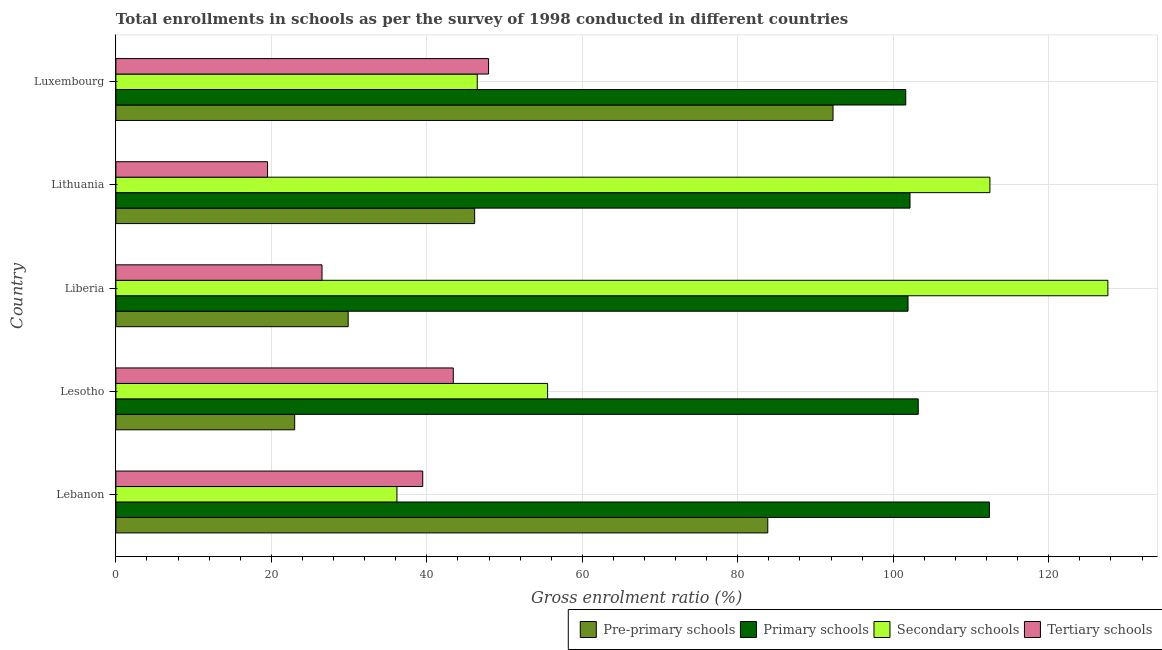How many groups of bars are there?
Make the answer very short. 5. Are the number of bars per tick equal to the number of legend labels?
Keep it short and to the point. Yes. Are the number of bars on each tick of the Y-axis equal?
Your answer should be very brief. Yes. How many bars are there on the 4th tick from the top?
Offer a very short reply. 4. What is the label of the 3rd group of bars from the top?
Your answer should be compact. Liberia. What is the gross enrolment ratio in secondary schools in Liberia?
Offer a terse response. 127.61. Across all countries, what is the maximum gross enrolment ratio in pre-primary schools?
Your answer should be very brief. 92.25. Across all countries, what is the minimum gross enrolment ratio in primary schools?
Keep it short and to the point. 101.6. In which country was the gross enrolment ratio in primary schools maximum?
Give a very brief answer. Lebanon. In which country was the gross enrolment ratio in tertiary schools minimum?
Your answer should be very brief. Lithuania. What is the total gross enrolment ratio in pre-primary schools in the graph?
Your response must be concise. 275.14. What is the difference between the gross enrolment ratio in primary schools in Lesotho and that in Liberia?
Provide a short and direct response. 1.31. What is the difference between the gross enrolment ratio in secondary schools in Lithuania and the gross enrolment ratio in pre-primary schools in Lesotho?
Your response must be concise. 89.43. What is the average gross enrolment ratio in tertiary schools per country?
Provide a succinct answer. 35.37. What is the difference between the gross enrolment ratio in tertiary schools and gross enrolment ratio in pre-primary schools in Lesotho?
Your answer should be compact. 20.4. In how many countries, is the gross enrolment ratio in tertiary schools greater than 100 %?
Provide a short and direct response. 0. What is the ratio of the gross enrolment ratio in primary schools in Lebanon to that in Liberia?
Offer a terse response. 1.1. What is the difference between the highest and the second highest gross enrolment ratio in pre-primary schools?
Your response must be concise. 8.39. What is the difference between the highest and the lowest gross enrolment ratio in pre-primary schools?
Provide a succinct answer. 69.25. Is it the case that in every country, the sum of the gross enrolment ratio in primary schools and gross enrolment ratio in tertiary schools is greater than the sum of gross enrolment ratio in secondary schools and gross enrolment ratio in pre-primary schools?
Offer a terse response. No. What does the 1st bar from the top in Lithuania represents?
Give a very brief answer. Tertiary schools. What does the 2nd bar from the bottom in Luxembourg represents?
Your response must be concise. Primary schools. How many countries are there in the graph?
Offer a terse response. 5. What is the difference between two consecutive major ticks on the X-axis?
Give a very brief answer. 20. Are the values on the major ticks of X-axis written in scientific E-notation?
Your response must be concise. No. Does the graph contain any zero values?
Your answer should be very brief. No. What is the title of the graph?
Offer a very short reply. Total enrollments in schools as per the survey of 1998 conducted in different countries. Does "Social Insurance" appear as one of the legend labels in the graph?
Keep it short and to the point. No. What is the label or title of the X-axis?
Provide a succinct answer. Gross enrolment ratio (%). What is the Gross enrolment ratio (%) in Pre-primary schools in Lebanon?
Make the answer very short. 83.86. What is the Gross enrolment ratio (%) of Primary schools in Lebanon?
Your answer should be very brief. 112.37. What is the Gross enrolment ratio (%) in Secondary schools in Lebanon?
Keep it short and to the point. 36.15. What is the Gross enrolment ratio (%) in Tertiary schools in Lebanon?
Your response must be concise. 39.47. What is the Gross enrolment ratio (%) of Pre-primary schools in Lesotho?
Keep it short and to the point. 23. What is the Gross enrolment ratio (%) of Primary schools in Lesotho?
Ensure brevity in your answer.  103.21. What is the Gross enrolment ratio (%) of Secondary schools in Lesotho?
Provide a succinct answer. 55.54. What is the Gross enrolment ratio (%) of Tertiary schools in Lesotho?
Provide a succinct answer. 43.4. What is the Gross enrolment ratio (%) of Pre-primary schools in Liberia?
Make the answer very short. 29.88. What is the Gross enrolment ratio (%) in Primary schools in Liberia?
Your answer should be compact. 101.9. What is the Gross enrolment ratio (%) of Secondary schools in Liberia?
Keep it short and to the point. 127.61. What is the Gross enrolment ratio (%) in Tertiary schools in Liberia?
Keep it short and to the point. 26.51. What is the Gross enrolment ratio (%) of Pre-primary schools in Lithuania?
Keep it short and to the point. 46.15. What is the Gross enrolment ratio (%) of Primary schools in Lithuania?
Provide a short and direct response. 102.15. What is the Gross enrolment ratio (%) in Secondary schools in Lithuania?
Make the answer very short. 112.43. What is the Gross enrolment ratio (%) in Tertiary schools in Lithuania?
Make the answer very short. 19.51. What is the Gross enrolment ratio (%) of Pre-primary schools in Luxembourg?
Ensure brevity in your answer.  92.25. What is the Gross enrolment ratio (%) of Primary schools in Luxembourg?
Offer a very short reply. 101.6. What is the Gross enrolment ratio (%) in Secondary schools in Luxembourg?
Give a very brief answer. 46.49. What is the Gross enrolment ratio (%) of Tertiary schools in Luxembourg?
Ensure brevity in your answer.  47.94. Across all countries, what is the maximum Gross enrolment ratio (%) of Pre-primary schools?
Your answer should be compact. 92.25. Across all countries, what is the maximum Gross enrolment ratio (%) in Primary schools?
Ensure brevity in your answer.  112.37. Across all countries, what is the maximum Gross enrolment ratio (%) in Secondary schools?
Provide a short and direct response. 127.61. Across all countries, what is the maximum Gross enrolment ratio (%) in Tertiary schools?
Offer a terse response. 47.94. Across all countries, what is the minimum Gross enrolment ratio (%) of Pre-primary schools?
Your response must be concise. 23. Across all countries, what is the minimum Gross enrolment ratio (%) in Primary schools?
Ensure brevity in your answer.  101.6. Across all countries, what is the minimum Gross enrolment ratio (%) in Secondary schools?
Give a very brief answer. 36.15. Across all countries, what is the minimum Gross enrolment ratio (%) of Tertiary schools?
Make the answer very short. 19.51. What is the total Gross enrolment ratio (%) of Pre-primary schools in the graph?
Provide a short and direct response. 275.14. What is the total Gross enrolment ratio (%) in Primary schools in the graph?
Offer a terse response. 521.23. What is the total Gross enrolment ratio (%) in Secondary schools in the graph?
Your answer should be very brief. 378.22. What is the total Gross enrolment ratio (%) in Tertiary schools in the graph?
Provide a succinct answer. 176.84. What is the difference between the Gross enrolment ratio (%) of Pre-primary schools in Lebanon and that in Lesotho?
Your answer should be compact. 60.86. What is the difference between the Gross enrolment ratio (%) in Primary schools in Lebanon and that in Lesotho?
Your response must be concise. 9.16. What is the difference between the Gross enrolment ratio (%) in Secondary schools in Lebanon and that in Lesotho?
Offer a very short reply. -19.38. What is the difference between the Gross enrolment ratio (%) in Tertiary schools in Lebanon and that in Lesotho?
Provide a short and direct response. -3.93. What is the difference between the Gross enrolment ratio (%) in Pre-primary schools in Lebanon and that in Liberia?
Your response must be concise. 53.98. What is the difference between the Gross enrolment ratio (%) in Primary schools in Lebanon and that in Liberia?
Offer a very short reply. 10.47. What is the difference between the Gross enrolment ratio (%) in Secondary schools in Lebanon and that in Liberia?
Offer a very short reply. -91.46. What is the difference between the Gross enrolment ratio (%) of Tertiary schools in Lebanon and that in Liberia?
Provide a succinct answer. 12.96. What is the difference between the Gross enrolment ratio (%) in Pre-primary schools in Lebanon and that in Lithuania?
Provide a short and direct response. 37.71. What is the difference between the Gross enrolment ratio (%) in Primary schools in Lebanon and that in Lithuania?
Your answer should be compact. 10.22. What is the difference between the Gross enrolment ratio (%) of Secondary schools in Lebanon and that in Lithuania?
Provide a short and direct response. -76.28. What is the difference between the Gross enrolment ratio (%) of Tertiary schools in Lebanon and that in Lithuania?
Give a very brief answer. 19.96. What is the difference between the Gross enrolment ratio (%) of Pre-primary schools in Lebanon and that in Luxembourg?
Make the answer very short. -8.39. What is the difference between the Gross enrolment ratio (%) of Primary schools in Lebanon and that in Luxembourg?
Make the answer very short. 10.76. What is the difference between the Gross enrolment ratio (%) in Secondary schools in Lebanon and that in Luxembourg?
Make the answer very short. -10.33. What is the difference between the Gross enrolment ratio (%) in Tertiary schools in Lebanon and that in Luxembourg?
Ensure brevity in your answer.  -8.47. What is the difference between the Gross enrolment ratio (%) in Pre-primary schools in Lesotho and that in Liberia?
Keep it short and to the point. -6.88. What is the difference between the Gross enrolment ratio (%) in Primary schools in Lesotho and that in Liberia?
Your answer should be compact. 1.31. What is the difference between the Gross enrolment ratio (%) in Secondary schools in Lesotho and that in Liberia?
Provide a succinct answer. -72.07. What is the difference between the Gross enrolment ratio (%) of Tertiary schools in Lesotho and that in Liberia?
Your answer should be compact. 16.89. What is the difference between the Gross enrolment ratio (%) of Pre-primary schools in Lesotho and that in Lithuania?
Give a very brief answer. -23.15. What is the difference between the Gross enrolment ratio (%) in Primary schools in Lesotho and that in Lithuania?
Ensure brevity in your answer.  1.06. What is the difference between the Gross enrolment ratio (%) in Secondary schools in Lesotho and that in Lithuania?
Keep it short and to the point. -56.89. What is the difference between the Gross enrolment ratio (%) of Tertiary schools in Lesotho and that in Lithuania?
Offer a terse response. 23.89. What is the difference between the Gross enrolment ratio (%) in Pre-primary schools in Lesotho and that in Luxembourg?
Your answer should be very brief. -69.25. What is the difference between the Gross enrolment ratio (%) of Primary schools in Lesotho and that in Luxembourg?
Your answer should be compact. 1.61. What is the difference between the Gross enrolment ratio (%) of Secondary schools in Lesotho and that in Luxembourg?
Provide a short and direct response. 9.05. What is the difference between the Gross enrolment ratio (%) of Tertiary schools in Lesotho and that in Luxembourg?
Give a very brief answer. -4.54. What is the difference between the Gross enrolment ratio (%) of Pre-primary schools in Liberia and that in Lithuania?
Your answer should be compact. -16.27. What is the difference between the Gross enrolment ratio (%) of Primary schools in Liberia and that in Lithuania?
Your response must be concise. -0.25. What is the difference between the Gross enrolment ratio (%) in Secondary schools in Liberia and that in Lithuania?
Offer a very short reply. 15.18. What is the difference between the Gross enrolment ratio (%) of Tertiary schools in Liberia and that in Lithuania?
Your answer should be compact. 7.01. What is the difference between the Gross enrolment ratio (%) of Pre-primary schools in Liberia and that in Luxembourg?
Your answer should be compact. -62.37. What is the difference between the Gross enrolment ratio (%) in Primary schools in Liberia and that in Luxembourg?
Your response must be concise. 0.29. What is the difference between the Gross enrolment ratio (%) in Secondary schools in Liberia and that in Luxembourg?
Offer a terse response. 81.12. What is the difference between the Gross enrolment ratio (%) of Tertiary schools in Liberia and that in Luxembourg?
Make the answer very short. -21.43. What is the difference between the Gross enrolment ratio (%) of Pre-primary schools in Lithuania and that in Luxembourg?
Your answer should be very brief. -46.1. What is the difference between the Gross enrolment ratio (%) of Primary schools in Lithuania and that in Luxembourg?
Your response must be concise. 0.55. What is the difference between the Gross enrolment ratio (%) in Secondary schools in Lithuania and that in Luxembourg?
Offer a terse response. 65.95. What is the difference between the Gross enrolment ratio (%) in Tertiary schools in Lithuania and that in Luxembourg?
Offer a terse response. -28.43. What is the difference between the Gross enrolment ratio (%) in Pre-primary schools in Lebanon and the Gross enrolment ratio (%) in Primary schools in Lesotho?
Give a very brief answer. -19.35. What is the difference between the Gross enrolment ratio (%) of Pre-primary schools in Lebanon and the Gross enrolment ratio (%) of Secondary schools in Lesotho?
Make the answer very short. 28.32. What is the difference between the Gross enrolment ratio (%) in Pre-primary schools in Lebanon and the Gross enrolment ratio (%) in Tertiary schools in Lesotho?
Provide a short and direct response. 40.45. What is the difference between the Gross enrolment ratio (%) of Primary schools in Lebanon and the Gross enrolment ratio (%) of Secondary schools in Lesotho?
Your response must be concise. 56.83. What is the difference between the Gross enrolment ratio (%) in Primary schools in Lebanon and the Gross enrolment ratio (%) in Tertiary schools in Lesotho?
Offer a terse response. 68.96. What is the difference between the Gross enrolment ratio (%) in Secondary schools in Lebanon and the Gross enrolment ratio (%) in Tertiary schools in Lesotho?
Ensure brevity in your answer.  -7.25. What is the difference between the Gross enrolment ratio (%) of Pre-primary schools in Lebanon and the Gross enrolment ratio (%) of Primary schools in Liberia?
Your answer should be very brief. -18.04. What is the difference between the Gross enrolment ratio (%) in Pre-primary schools in Lebanon and the Gross enrolment ratio (%) in Secondary schools in Liberia?
Provide a succinct answer. -43.75. What is the difference between the Gross enrolment ratio (%) in Pre-primary schools in Lebanon and the Gross enrolment ratio (%) in Tertiary schools in Liberia?
Your answer should be compact. 57.34. What is the difference between the Gross enrolment ratio (%) in Primary schools in Lebanon and the Gross enrolment ratio (%) in Secondary schools in Liberia?
Offer a terse response. -15.24. What is the difference between the Gross enrolment ratio (%) in Primary schools in Lebanon and the Gross enrolment ratio (%) in Tertiary schools in Liberia?
Offer a terse response. 85.85. What is the difference between the Gross enrolment ratio (%) of Secondary schools in Lebanon and the Gross enrolment ratio (%) of Tertiary schools in Liberia?
Offer a terse response. 9.64. What is the difference between the Gross enrolment ratio (%) of Pre-primary schools in Lebanon and the Gross enrolment ratio (%) of Primary schools in Lithuania?
Keep it short and to the point. -18.29. What is the difference between the Gross enrolment ratio (%) of Pre-primary schools in Lebanon and the Gross enrolment ratio (%) of Secondary schools in Lithuania?
Your response must be concise. -28.57. What is the difference between the Gross enrolment ratio (%) of Pre-primary schools in Lebanon and the Gross enrolment ratio (%) of Tertiary schools in Lithuania?
Offer a very short reply. 64.35. What is the difference between the Gross enrolment ratio (%) of Primary schools in Lebanon and the Gross enrolment ratio (%) of Secondary schools in Lithuania?
Provide a succinct answer. -0.06. What is the difference between the Gross enrolment ratio (%) in Primary schools in Lebanon and the Gross enrolment ratio (%) in Tertiary schools in Lithuania?
Offer a terse response. 92.86. What is the difference between the Gross enrolment ratio (%) in Secondary schools in Lebanon and the Gross enrolment ratio (%) in Tertiary schools in Lithuania?
Offer a terse response. 16.64. What is the difference between the Gross enrolment ratio (%) of Pre-primary schools in Lebanon and the Gross enrolment ratio (%) of Primary schools in Luxembourg?
Ensure brevity in your answer.  -17.75. What is the difference between the Gross enrolment ratio (%) in Pre-primary schools in Lebanon and the Gross enrolment ratio (%) in Secondary schools in Luxembourg?
Offer a terse response. 37.37. What is the difference between the Gross enrolment ratio (%) in Pre-primary schools in Lebanon and the Gross enrolment ratio (%) in Tertiary schools in Luxembourg?
Provide a short and direct response. 35.92. What is the difference between the Gross enrolment ratio (%) in Primary schools in Lebanon and the Gross enrolment ratio (%) in Secondary schools in Luxembourg?
Make the answer very short. 65.88. What is the difference between the Gross enrolment ratio (%) of Primary schools in Lebanon and the Gross enrolment ratio (%) of Tertiary schools in Luxembourg?
Provide a succinct answer. 64.43. What is the difference between the Gross enrolment ratio (%) in Secondary schools in Lebanon and the Gross enrolment ratio (%) in Tertiary schools in Luxembourg?
Make the answer very short. -11.79. What is the difference between the Gross enrolment ratio (%) in Pre-primary schools in Lesotho and the Gross enrolment ratio (%) in Primary schools in Liberia?
Offer a terse response. -78.9. What is the difference between the Gross enrolment ratio (%) of Pre-primary schools in Lesotho and the Gross enrolment ratio (%) of Secondary schools in Liberia?
Offer a very short reply. -104.61. What is the difference between the Gross enrolment ratio (%) of Pre-primary schools in Lesotho and the Gross enrolment ratio (%) of Tertiary schools in Liberia?
Your response must be concise. -3.51. What is the difference between the Gross enrolment ratio (%) of Primary schools in Lesotho and the Gross enrolment ratio (%) of Secondary schools in Liberia?
Offer a very short reply. -24.4. What is the difference between the Gross enrolment ratio (%) of Primary schools in Lesotho and the Gross enrolment ratio (%) of Tertiary schools in Liberia?
Ensure brevity in your answer.  76.7. What is the difference between the Gross enrolment ratio (%) in Secondary schools in Lesotho and the Gross enrolment ratio (%) in Tertiary schools in Liberia?
Provide a short and direct response. 29.02. What is the difference between the Gross enrolment ratio (%) of Pre-primary schools in Lesotho and the Gross enrolment ratio (%) of Primary schools in Lithuania?
Ensure brevity in your answer.  -79.15. What is the difference between the Gross enrolment ratio (%) in Pre-primary schools in Lesotho and the Gross enrolment ratio (%) in Secondary schools in Lithuania?
Keep it short and to the point. -89.43. What is the difference between the Gross enrolment ratio (%) of Pre-primary schools in Lesotho and the Gross enrolment ratio (%) of Tertiary schools in Lithuania?
Ensure brevity in your answer.  3.49. What is the difference between the Gross enrolment ratio (%) of Primary schools in Lesotho and the Gross enrolment ratio (%) of Secondary schools in Lithuania?
Your answer should be compact. -9.22. What is the difference between the Gross enrolment ratio (%) in Primary schools in Lesotho and the Gross enrolment ratio (%) in Tertiary schools in Lithuania?
Keep it short and to the point. 83.7. What is the difference between the Gross enrolment ratio (%) of Secondary schools in Lesotho and the Gross enrolment ratio (%) of Tertiary schools in Lithuania?
Offer a very short reply. 36.03. What is the difference between the Gross enrolment ratio (%) in Pre-primary schools in Lesotho and the Gross enrolment ratio (%) in Primary schools in Luxembourg?
Provide a short and direct response. -78.6. What is the difference between the Gross enrolment ratio (%) of Pre-primary schools in Lesotho and the Gross enrolment ratio (%) of Secondary schools in Luxembourg?
Ensure brevity in your answer.  -23.49. What is the difference between the Gross enrolment ratio (%) of Pre-primary schools in Lesotho and the Gross enrolment ratio (%) of Tertiary schools in Luxembourg?
Your answer should be very brief. -24.94. What is the difference between the Gross enrolment ratio (%) of Primary schools in Lesotho and the Gross enrolment ratio (%) of Secondary schools in Luxembourg?
Your answer should be very brief. 56.72. What is the difference between the Gross enrolment ratio (%) in Primary schools in Lesotho and the Gross enrolment ratio (%) in Tertiary schools in Luxembourg?
Make the answer very short. 55.27. What is the difference between the Gross enrolment ratio (%) in Secondary schools in Lesotho and the Gross enrolment ratio (%) in Tertiary schools in Luxembourg?
Your answer should be compact. 7.6. What is the difference between the Gross enrolment ratio (%) of Pre-primary schools in Liberia and the Gross enrolment ratio (%) of Primary schools in Lithuania?
Your answer should be compact. -72.27. What is the difference between the Gross enrolment ratio (%) in Pre-primary schools in Liberia and the Gross enrolment ratio (%) in Secondary schools in Lithuania?
Offer a very short reply. -82.55. What is the difference between the Gross enrolment ratio (%) in Pre-primary schools in Liberia and the Gross enrolment ratio (%) in Tertiary schools in Lithuania?
Ensure brevity in your answer.  10.37. What is the difference between the Gross enrolment ratio (%) of Primary schools in Liberia and the Gross enrolment ratio (%) of Secondary schools in Lithuania?
Make the answer very short. -10.53. What is the difference between the Gross enrolment ratio (%) of Primary schools in Liberia and the Gross enrolment ratio (%) of Tertiary schools in Lithuania?
Make the answer very short. 82.39. What is the difference between the Gross enrolment ratio (%) of Secondary schools in Liberia and the Gross enrolment ratio (%) of Tertiary schools in Lithuania?
Your answer should be compact. 108.1. What is the difference between the Gross enrolment ratio (%) in Pre-primary schools in Liberia and the Gross enrolment ratio (%) in Primary schools in Luxembourg?
Provide a succinct answer. -71.72. What is the difference between the Gross enrolment ratio (%) in Pre-primary schools in Liberia and the Gross enrolment ratio (%) in Secondary schools in Luxembourg?
Provide a short and direct response. -16.6. What is the difference between the Gross enrolment ratio (%) of Pre-primary schools in Liberia and the Gross enrolment ratio (%) of Tertiary schools in Luxembourg?
Your answer should be compact. -18.06. What is the difference between the Gross enrolment ratio (%) in Primary schools in Liberia and the Gross enrolment ratio (%) in Secondary schools in Luxembourg?
Provide a succinct answer. 55.41. What is the difference between the Gross enrolment ratio (%) in Primary schools in Liberia and the Gross enrolment ratio (%) in Tertiary schools in Luxembourg?
Provide a short and direct response. 53.96. What is the difference between the Gross enrolment ratio (%) in Secondary schools in Liberia and the Gross enrolment ratio (%) in Tertiary schools in Luxembourg?
Provide a succinct answer. 79.67. What is the difference between the Gross enrolment ratio (%) of Pre-primary schools in Lithuania and the Gross enrolment ratio (%) of Primary schools in Luxembourg?
Your answer should be compact. -55.45. What is the difference between the Gross enrolment ratio (%) of Pre-primary schools in Lithuania and the Gross enrolment ratio (%) of Secondary schools in Luxembourg?
Your response must be concise. -0.34. What is the difference between the Gross enrolment ratio (%) of Pre-primary schools in Lithuania and the Gross enrolment ratio (%) of Tertiary schools in Luxembourg?
Give a very brief answer. -1.79. What is the difference between the Gross enrolment ratio (%) of Primary schools in Lithuania and the Gross enrolment ratio (%) of Secondary schools in Luxembourg?
Provide a succinct answer. 55.66. What is the difference between the Gross enrolment ratio (%) in Primary schools in Lithuania and the Gross enrolment ratio (%) in Tertiary schools in Luxembourg?
Give a very brief answer. 54.21. What is the difference between the Gross enrolment ratio (%) of Secondary schools in Lithuania and the Gross enrolment ratio (%) of Tertiary schools in Luxembourg?
Provide a short and direct response. 64.49. What is the average Gross enrolment ratio (%) of Pre-primary schools per country?
Ensure brevity in your answer.  55.03. What is the average Gross enrolment ratio (%) of Primary schools per country?
Your answer should be very brief. 104.25. What is the average Gross enrolment ratio (%) of Secondary schools per country?
Your answer should be compact. 75.64. What is the average Gross enrolment ratio (%) in Tertiary schools per country?
Your answer should be compact. 35.37. What is the difference between the Gross enrolment ratio (%) in Pre-primary schools and Gross enrolment ratio (%) in Primary schools in Lebanon?
Your response must be concise. -28.51. What is the difference between the Gross enrolment ratio (%) in Pre-primary schools and Gross enrolment ratio (%) in Secondary schools in Lebanon?
Give a very brief answer. 47.7. What is the difference between the Gross enrolment ratio (%) in Pre-primary schools and Gross enrolment ratio (%) in Tertiary schools in Lebanon?
Your answer should be compact. 44.39. What is the difference between the Gross enrolment ratio (%) of Primary schools and Gross enrolment ratio (%) of Secondary schools in Lebanon?
Offer a very short reply. 76.22. What is the difference between the Gross enrolment ratio (%) of Primary schools and Gross enrolment ratio (%) of Tertiary schools in Lebanon?
Ensure brevity in your answer.  72.9. What is the difference between the Gross enrolment ratio (%) of Secondary schools and Gross enrolment ratio (%) of Tertiary schools in Lebanon?
Offer a terse response. -3.32. What is the difference between the Gross enrolment ratio (%) of Pre-primary schools and Gross enrolment ratio (%) of Primary schools in Lesotho?
Provide a short and direct response. -80.21. What is the difference between the Gross enrolment ratio (%) of Pre-primary schools and Gross enrolment ratio (%) of Secondary schools in Lesotho?
Ensure brevity in your answer.  -32.54. What is the difference between the Gross enrolment ratio (%) in Pre-primary schools and Gross enrolment ratio (%) in Tertiary schools in Lesotho?
Your answer should be very brief. -20.4. What is the difference between the Gross enrolment ratio (%) in Primary schools and Gross enrolment ratio (%) in Secondary schools in Lesotho?
Your answer should be compact. 47.67. What is the difference between the Gross enrolment ratio (%) of Primary schools and Gross enrolment ratio (%) of Tertiary schools in Lesotho?
Ensure brevity in your answer.  59.81. What is the difference between the Gross enrolment ratio (%) in Secondary schools and Gross enrolment ratio (%) in Tertiary schools in Lesotho?
Your answer should be very brief. 12.13. What is the difference between the Gross enrolment ratio (%) in Pre-primary schools and Gross enrolment ratio (%) in Primary schools in Liberia?
Make the answer very short. -72.02. What is the difference between the Gross enrolment ratio (%) in Pre-primary schools and Gross enrolment ratio (%) in Secondary schools in Liberia?
Your answer should be very brief. -97.73. What is the difference between the Gross enrolment ratio (%) in Pre-primary schools and Gross enrolment ratio (%) in Tertiary schools in Liberia?
Ensure brevity in your answer.  3.37. What is the difference between the Gross enrolment ratio (%) of Primary schools and Gross enrolment ratio (%) of Secondary schools in Liberia?
Give a very brief answer. -25.71. What is the difference between the Gross enrolment ratio (%) of Primary schools and Gross enrolment ratio (%) of Tertiary schools in Liberia?
Your answer should be compact. 75.38. What is the difference between the Gross enrolment ratio (%) of Secondary schools and Gross enrolment ratio (%) of Tertiary schools in Liberia?
Ensure brevity in your answer.  101.09. What is the difference between the Gross enrolment ratio (%) in Pre-primary schools and Gross enrolment ratio (%) in Primary schools in Lithuania?
Ensure brevity in your answer.  -56. What is the difference between the Gross enrolment ratio (%) in Pre-primary schools and Gross enrolment ratio (%) in Secondary schools in Lithuania?
Provide a succinct answer. -66.28. What is the difference between the Gross enrolment ratio (%) of Pre-primary schools and Gross enrolment ratio (%) of Tertiary schools in Lithuania?
Make the answer very short. 26.64. What is the difference between the Gross enrolment ratio (%) of Primary schools and Gross enrolment ratio (%) of Secondary schools in Lithuania?
Your answer should be very brief. -10.28. What is the difference between the Gross enrolment ratio (%) of Primary schools and Gross enrolment ratio (%) of Tertiary schools in Lithuania?
Give a very brief answer. 82.64. What is the difference between the Gross enrolment ratio (%) of Secondary schools and Gross enrolment ratio (%) of Tertiary schools in Lithuania?
Provide a succinct answer. 92.92. What is the difference between the Gross enrolment ratio (%) of Pre-primary schools and Gross enrolment ratio (%) of Primary schools in Luxembourg?
Keep it short and to the point. -9.35. What is the difference between the Gross enrolment ratio (%) of Pre-primary schools and Gross enrolment ratio (%) of Secondary schools in Luxembourg?
Give a very brief answer. 45.76. What is the difference between the Gross enrolment ratio (%) in Pre-primary schools and Gross enrolment ratio (%) in Tertiary schools in Luxembourg?
Make the answer very short. 44.31. What is the difference between the Gross enrolment ratio (%) of Primary schools and Gross enrolment ratio (%) of Secondary schools in Luxembourg?
Make the answer very short. 55.12. What is the difference between the Gross enrolment ratio (%) of Primary schools and Gross enrolment ratio (%) of Tertiary schools in Luxembourg?
Your answer should be very brief. 53.66. What is the difference between the Gross enrolment ratio (%) in Secondary schools and Gross enrolment ratio (%) in Tertiary schools in Luxembourg?
Provide a short and direct response. -1.45. What is the ratio of the Gross enrolment ratio (%) in Pre-primary schools in Lebanon to that in Lesotho?
Offer a terse response. 3.65. What is the ratio of the Gross enrolment ratio (%) of Primary schools in Lebanon to that in Lesotho?
Give a very brief answer. 1.09. What is the ratio of the Gross enrolment ratio (%) of Secondary schools in Lebanon to that in Lesotho?
Make the answer very short. 0.65. What is the ratio of the Gross enrolment ratio (%) in Tertiary schools in Lebanon to that in Lesotho?
Your response must be concise. 0.91. What is the ratio of the Gross enrolment ratio (%) in Pre-primary schools in Lebanon to that in Liberia?
Offer a very short reply. 2.81. What is the ratio of the Gross enrolment ratio (%) of Primary schools in Lebanon to that in Liberia?
Make the answer very short. 1.1. What is the ratio of the Gross enrolment ratio (%) of Secondary schools in Lebanon to that in Liberia?
Make the answer very short. 0.28. What is the ratio of the Gross enrolment ratio (%) of Tertiary schools in Lebanon to that in Liberia?
Offer a terse response. 1.49. What is the ratio of the Gross enrolment ratio (%) in Pre-primary schools in Lebanon to that in Lithuania?
Make the answer very short. 1.82. What is the ratio of the Gross enrolment ratio (%) in Primary schools in Lebanon to that in Lithuania?
Keep it short and to the point. 1.1. What is the ratio of the Gross enrolment ratio (%) of Secondary schools in Lebanon to that in Lithuania?
Give a very brief answer. 0.32. What is the ratio of the Gross enrolment ratio (%) in Tertiary schools in Lebanon to that in Lithuania?
Keep it short and to the point. 2.02. What is the ratio of the Gross enrolment ratio (%) of Pre-primary schools in Lebanon to that in Luxembourg?
Make the answer very short. 0.91. What is the ratio of the Gross enrolment ratio (%) in Primary schools in Lebanon to that in Luxembourg?
Offer a very short reply. 1.11. What is the ratio of the Gross enrolment ratio (%) in Secondary schools in Lebanon to that in Luxembourg?
Keep it short and to the point. 0.78. What is the ratio of the Gross enrolment ratio (%) in Tertiary schools in Lebanon to that in Luxembourg?
Ensure brevity in your answer.  0.82. What is the ratio of the Gross enrolment ratio (%) in Pre-primary schools in Lesotho to that in Liberia?
Ensure brevity in your answer.  0.77. What is the ratio of the Gross enrolment ratio (%) of Primary schools in Lesotho to that in Liberia?
Make the answer very short. 1.01. What is the ratio of the Gross enrolment ratio (%) of Secondary schools in Lesotho to that in Liberia?
Offer a very short reply. 0.44. What is the ratio of the Gross enrolment ratio (%) in Tertiary schools in Lesotho to that in Liberia?
Provide a short and direct response. 1.64. What is the ratio of the Gross enrolment ratio (%) of Pre-primary schools in Lesotho to that in Lithuania?
Provide a short and direct response. 0.5. What is the ratio of the Gross enrolment ratio (%) of Primary schools in Lesotho to that in Lithuania?
Your answer should be compact. 1.01. What is the ratio of the Gross enrolment ratio (%) in Secondary schools in Lesotho to that in Lithuania?
Ensure brevity in your answer.  0.49. What is the ratio of the Gross enrolment ratio (%) of Tertiary schools in Lesotho to that in Lithuania?
Your answer should be very brief. 2.22. What is the ratio of the Gross enrolment ratio (%) of Pre-primary schools in Lesotho to that in Luxembourg?
Provide a short and direct response. 0.25. What is the ratio of the Gross enrolment ratio (%) of Primary schools in Lesotho to that in Luxembourg?
Provide a succinct answer. 1.02. What is the ratio of the Gross enrolment ratio (%) in Secondary schools in Lesotho to that in Luxembourg?
Provide a short and direct response. 1.19. What is the ratio of the Gross enrolment ratio (%) of Tertiary schools in Lesotho to that in Luxembourg?
Your response must be concise. 0.91. What is the ratio of the Gross enrolment ratio (%) of Pre-primary schools in Liberia to that in Lithuania?
Your response must be concise. 0.65. What is the ratio of the Gross enrolment ratio (%) in Secondary schools in Liberia to that in Lithuania?
Ensure brevity in your answer.  1.14. What is the ratio of the Gross enrolment ratio (%) in Tertiary schools in Liberia to that in Lithuania?
Your response must be concise. 1.36. What is the ratio of the Gross enrolment ratio (%) of Pre-primary schools in Liberia to that in Luxembourg?
Provide a short and direct response. 0.32. What is the ratio of the Gross enrolment ratio (%) of Secondary schools in Liberia to that in Luxembourg?
Give a very brief answer. 2.75. What is the ratio of the Gross enrolment ratio (%) in Tertiary schools in Liberia to that in Luxembourg?
Your answer should be compact. 0.55. What is the ratio of the Gross enrolment ratio (%) in Pre-primary schools in Lithuania to that in Luxembourg?
Offer a terse response. 0.5. What is the ratio of the Gross enrolment ratio (%) in Primary schools in Lithuania to that in Luxembourg?
Give a very brief answer. 1.01. What is the ratio of the Gross enrolment ratio (%) in Secondary schools in Lithuania to that in Luxembourg?
Give a very brief answer. 2.42. What is the ratio of the Gross enrolment ratio (%) of Tertiary schools in Lithuania to that in Luxembourg?
Offer a terse response. 0.41. What is the difference between the highest and the second highest Gross enrolment ratio (%) in Pre-primary schools?
Your answer should be compact. 8.39. What is the difference between the highest and the second highest Gross enrolment ratio (%) of Primary schools?
Provide a succinct answer. 9.16. What is the difference between the highest and the second highest Gross enrolment ratio (%) of Secondary schools?
Offer a terse response. 15.18. What is the difference between the highest and the second highest Gross enrolment ratio (%) in Tertiary schools?
Make the answer very short. 4.54. What is the difference between the highest and the lowest Gross enrolment ratio (%) in Pre-primary schools?
Keep it short and to the point. 69.25. What is the difference between the highest and the lowest Gross enrolment ratio (%) in Primary schools?
Provide a short and direct response. 10.76. What is the difference between the highest and the lowest Gross enrolment ratio (%) of Secondary schools?
Your answer should be very brief. 91.46. What is the difference between the highest and the lowest Gross enrolment ratio (%) of Tertiary schools?
Ensure brevity in your answer.  28.43. 